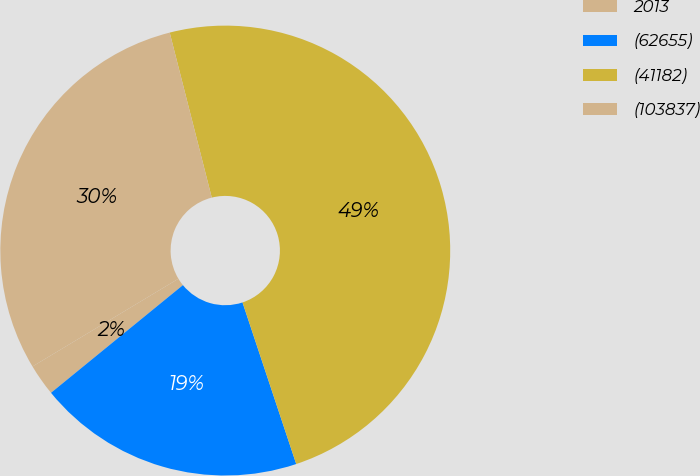<chart> <loc_0><loc_0><loc_500><loc_500><pie_chart><fcel>2013<fcel>(62655)<fcel>(41182)<fcel>(103837)<nl><fcel>2.28%<fcel>19.21%<fcel>48.86%<fcel>29.64%<nl></chart> 